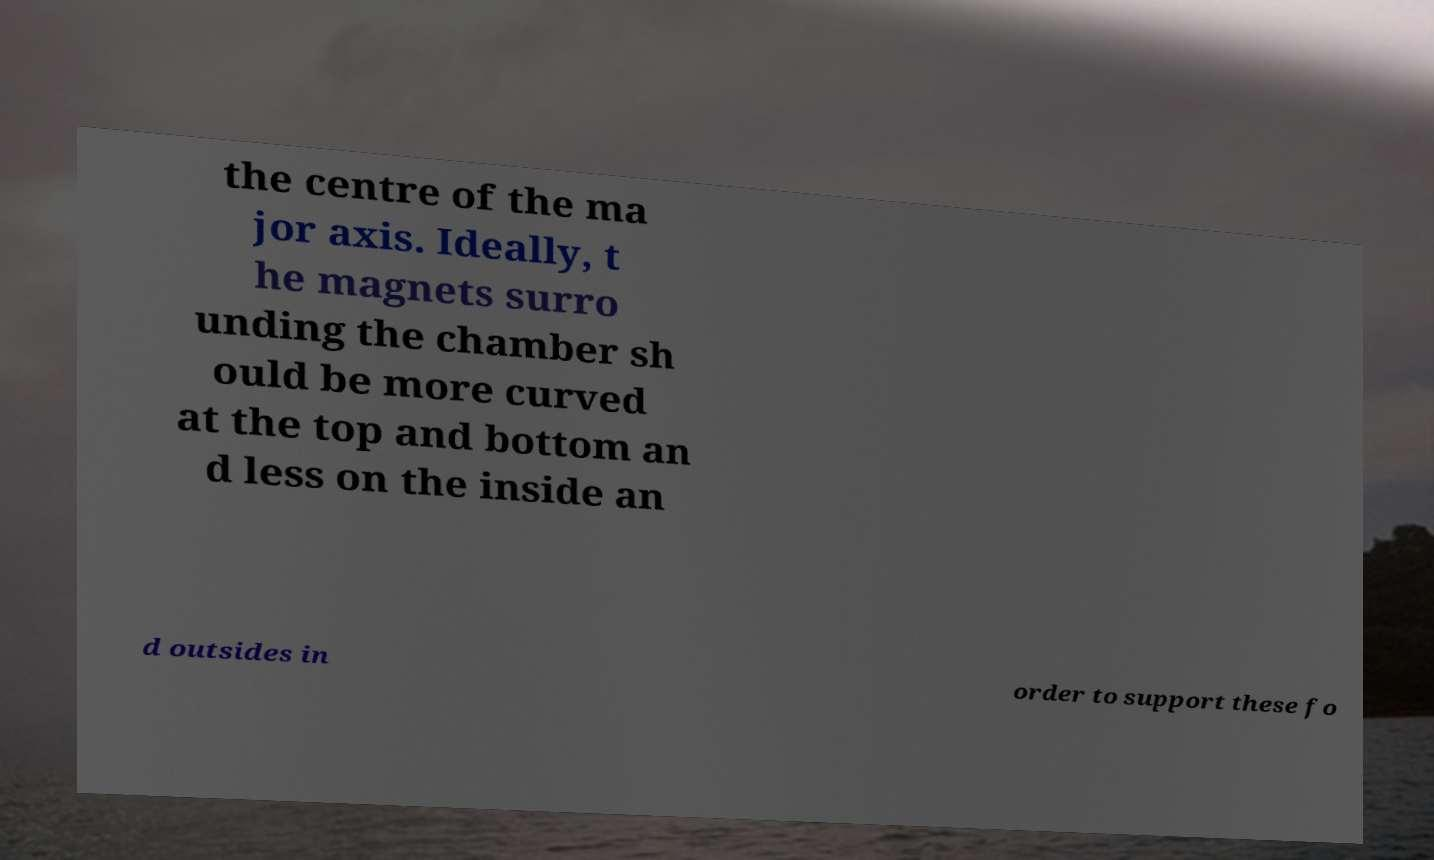For documentation purposes, I need the text within this image transcribed. Could you provide that? the centre of the ma jor axis. Ideally, t he magnets surro unding the chamber sh ould be more curved at the top and bottom an d less on the inside an d outsides in order to support these fo 